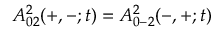Convert formula to latex. <formula><loc_0><loc_0><loc_500><loc_500>A _ { 0 2 } ^ { 2 } ( + , - ; t ) = A _ { 0 - 2 } ^ { 2 } ( - , + ; t )</formula> 